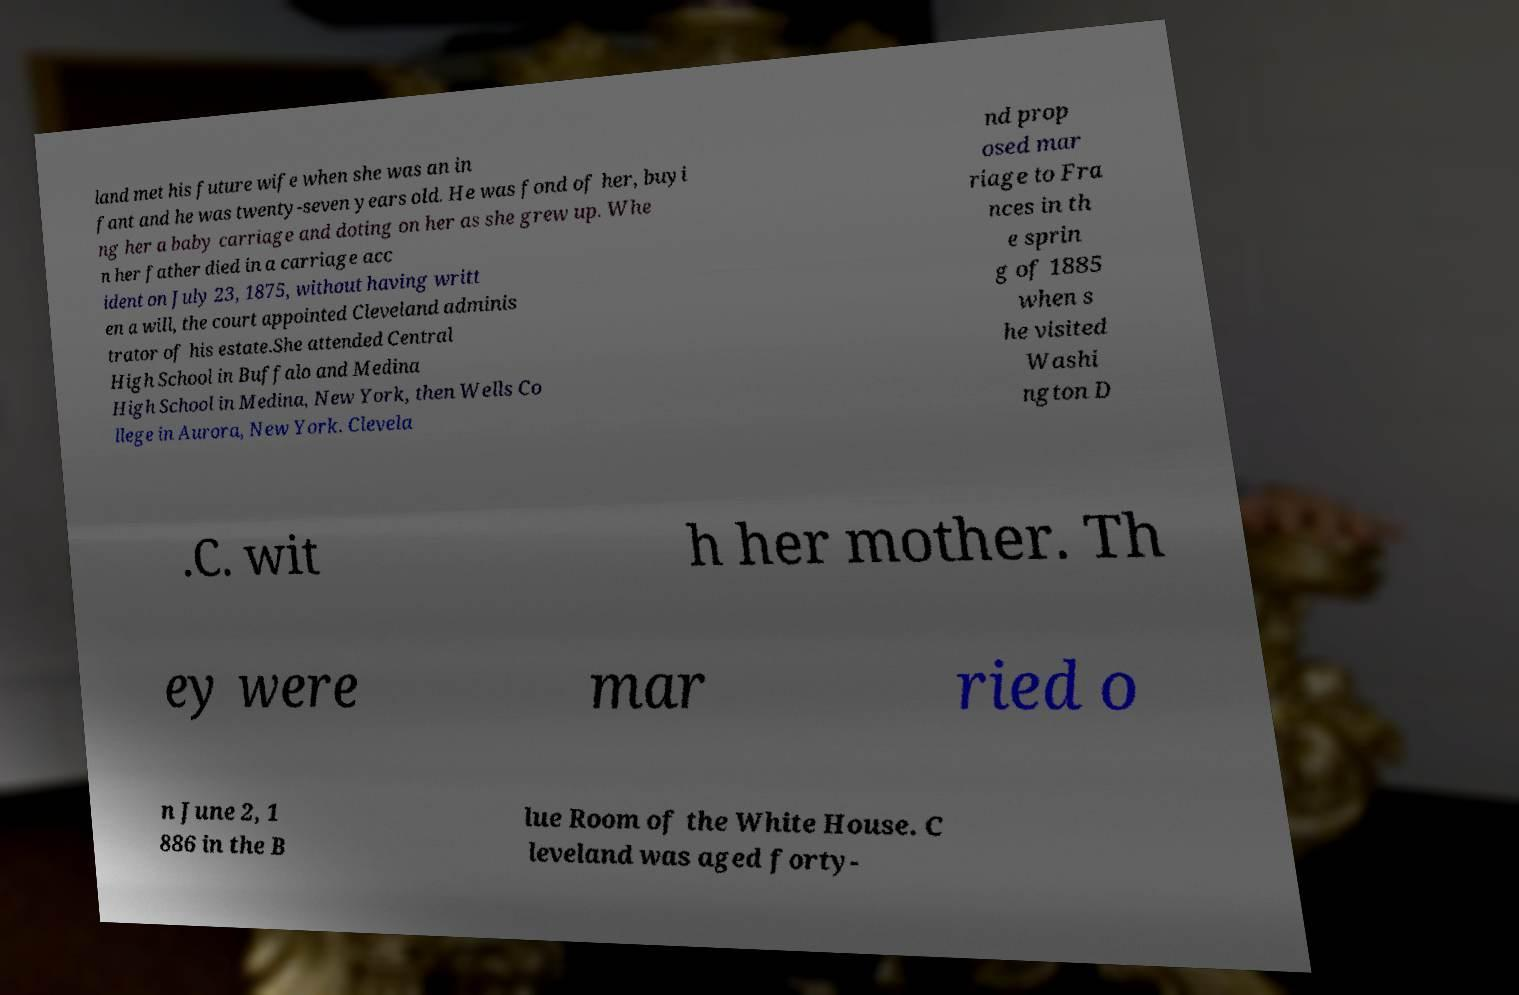Could you assist in decoding the text presented in this image and type it out clearly? land met his future wife when she was an in fant and he was twenty-seven years old. He was fond of her, buyi ng her a baby carriage and doting on her as she grew up. Whe n her father died in a carriage acc ident on July 23, 1875, without having writt en a will, the court appointed Cleveland adminis trator of his estate.She attended Central High School in Buffalo and Medina High School in Medina, New York, then Wells Co llege in Aurora, New York. Clevela nd prop osed mar riage to Fra nces in th e sprin g of 1885 when s he visited Washi ngton D .C. wit h her mother. Th ey were mar ried o n June 2, 1 886 in the B lue Room of the White House. C leveland was aged forty- 